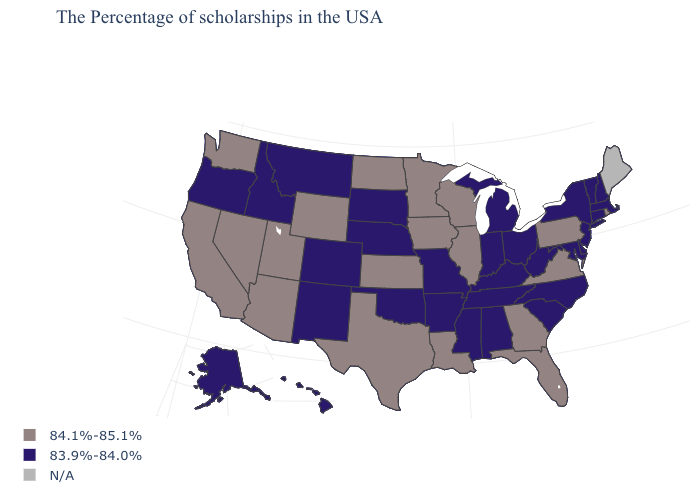What is the highest value in the MidWest ?
Short answer required. 84.1%-85.1%. Is the legend a continuous bar?
Answer briefly. No. Name the states that have a value in the range N/A?
Be succinct. Maine. Name the states that have a value in the range 83.9%-84.0%?
Answer briefly. Massachusetts, New Hampshire, Vermont, Connecticut, New York, New Jersey, Delaware, Maryland, North Carolina, South Carolina, West Virginia, Ohio, Michigan, Kentucky, Indiana, Alabama, Tennessee, Mississippi, Missouri, Arkansas, Nebraska, Oklahoma, South Dakota, Colorado, New Mexico, Montana, Idaho, Oregon, Alaska, Hawaii. What is the highest value in the USA?
Short answer required. 84.1%-85.1%. Does Vermont have the highest value in the USA?
Write a very short answer. No. What is the value of Arizona?
Give a very brief answer. 84.1%-85.1%. Which states have the highest value in the USA?
Concise answer only. Rhode Island, Pennsylvania, Virginia, Florida, Georgia, Wisconsin, Illinois, Louisiana, Minnesota, Iowa, Kansas, Texas, North Dakota, Wyoming, Utah, Arizona, Nevada, California, Washington. Name the states that have a value in the range 83.9%-84.0%?
Give a very brief answer. Massachusetts, New Hampshire, Vermont, Connecticut, New York, New Jersey, Delaware, Maryland, North Carolina, South Carolina, West Virginia, Ohio, Michigan, Kentucky, Indiana, Alabama, Tennessee, Mississippi, Missouri, Arkansas, Nebraska, Oklahoma, South Dakota, Colorado, New Mexico, Montana, Idaho, Oregon, Alaska, Hawaii. What is the lowest value in the Northeast?
Short answer required. 83.9%-84.0%. Does Oklahoma have the lowest value in the USA?
Concise answer only. Yes. What is the highest value in the West ?
Be succinct. 84.1%-85.1%. Which states have the highest value in the USA?
Answer briefly. Rhode Island, Pennsylvania, Virginia, Florida, Georgia, Wisconsin, Illinois, Louisiana, Minnesota, Iowa, Kansas, Texas, North Dakota, Wyoming, Utah, Arizona, Nevada, California, Washington. What is the lowest value in the South?
Quick response, please. 83.9%-84.0%. 